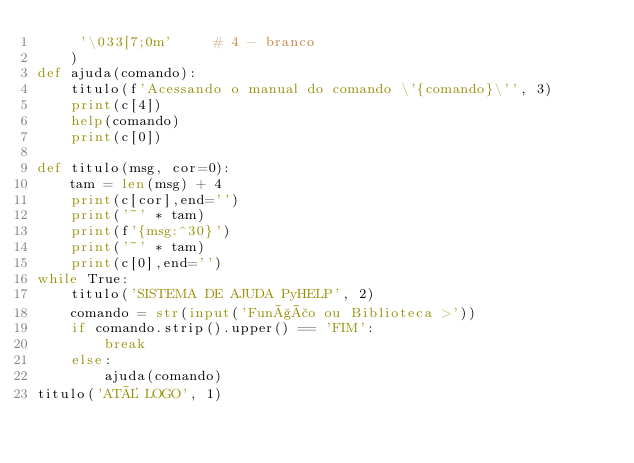<code> <loc_0><loc_0><loc_500><loc_500><_Python_>     '\033[7;0m'     # 4 - branco
    )
def ajuda(comando):
    titulo(f'Acessando o manual do comando \'{comando}\'', 3)
    print(c[4])
    help(comando)
    print(c[0])

def titulo(msg, cor=0):
    tam = len(msg) + 4
    print(c[cor],end='')
    print('~' * tam)
    print(f'{msg:^30}')
    print('~' * tam)
    print(c[0],end='')
while True:
    titulo('SISTEMA DE AJUDA PyHELP', 2)
    comando = str(input('Função ou Biblioteca >'))
    if comando.strip().upper() == 'FIM':
        break
    else:
        ajuda(comando)
titulo('ATÉ LOGO', 1)</code> 